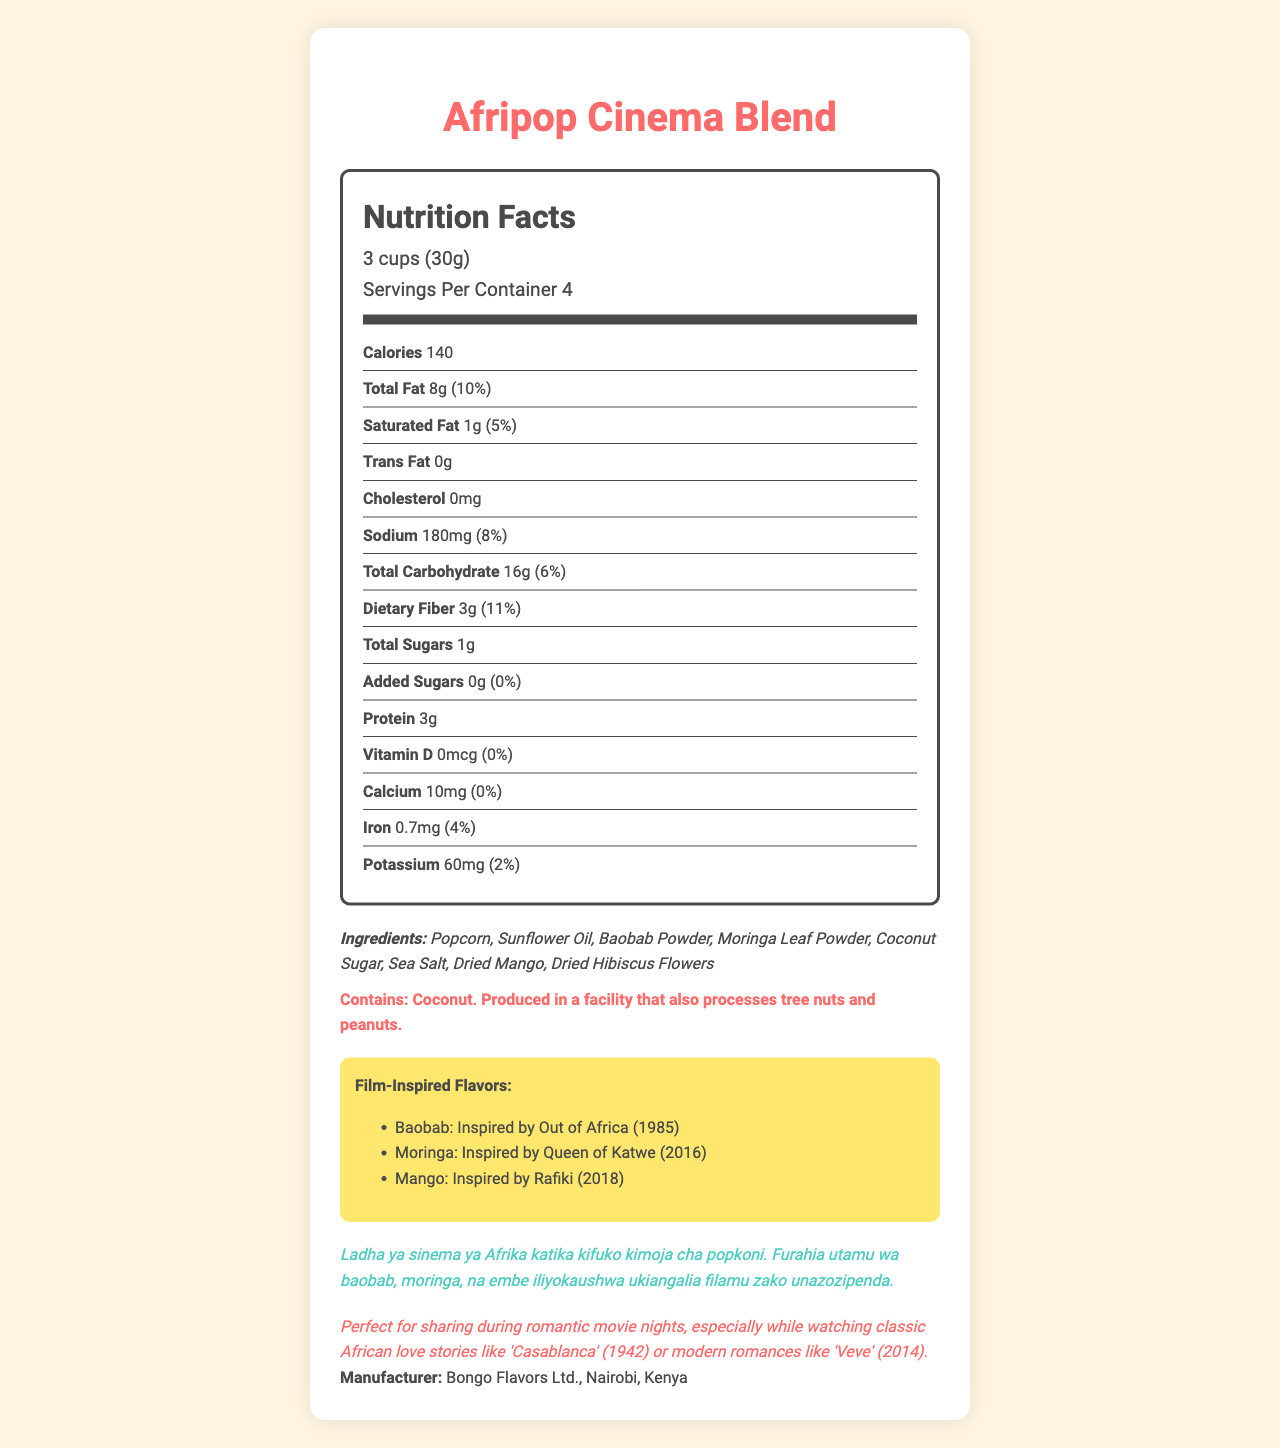what is the serving size? The serving size is located in the serving info section of the nutrition label as "3 cups (30g)".
Answer: 3 cups (30g) how many calories are in one serving? The number of calories per serving is listed under the "Calories" section of the nutrition facts.
Answer: 140 what is the total fat content per serving? The total fat content per serving is specified as "8g" in the nutrition facts and is followed by the percentage of the daily value.
Answer: 8g what ingredient in the Afripop Cinema Blend might cause an allergic reaction? The allergen information section indicates that the product contains coconut.
Answer: Coconut which nutrient contributes 11% of the daily value in one serving? The percent daily value for dietary fiber is 11%, as listed under the dietary fiber section of the nutrition facts.
Answer: Dietary Fiber what are the three film-inspired flavors in the Afripop Cinema Blend? The film-inspired flavors are listed in the film-inspired flavors section as Baobab, Moringa, and Mango.
Answer: Baobab, Moringa, Mango where is the Afripop Cinema Blend manufactured? The document states that the product is manufactured by Bongo Flavors Ltd. in Nairobi, Kenya.
Answer: Nairobi, Kenya how is the amount of sodium per serving quantified? The document quantifies the sodium content per serving as 180mg under the sodium section.
Answer: 180mg which flavor is inspired by the film "Queen of Katwe (2016)"? The film-inspired flavors section states that the Moringa flavor is inspired by "Queen of Katwe (2016)".
Answer: Moringa what is the dietary fiber content per serving, and how does it compare to the daily value percentage? A. 2g (7%) B. 3g (11%) C. 5g (15%) The dietary fiber content per serving is 3g, which is 11% of the daily value.
Answer: B which one of the following nutrients has the highest daily value percentage in one serving? A. Sodium B. Saturated Fat C. Calcium Sodium has the highest daily value percentage at 8%, compared to Saturated Fat at 5% and Calcium at 0%.
Answer: A is the Afripop Cinema Blend good for people trying to avoid added sugars? The nutrition facts show that the Afripop Cinema Blend contains 0g of added sugars, making it a good choice for those avoiding added sugars.
Answer: Yes summarize the main idea of the Afripop Cinema Blend nutrition facts label. This summary captures the overall content of the document, including the product name, serving size, nutritional details, ingredient list, allergen information, film-inspired flavors, and special notes on the product's romantic appeal.
Answer: The Afripop Cinema Blend is a specialty popcorn product inspired by African cinema, with serving size and nutritional details prominently displayed. It features flavors like Baobab, Moringa, and Mango, inspired by specific films. The product contains 140 calories per serving, with details on fats, sodium, carbohydrates, and other nutrients. The ingredient list includes items like popcorn, sunflower oil, baobab powder, and coconut sugar, and it notes allergen information related to coconut. The label also includes a Swahili product description and highlights its romantic appeal for movie nights. what is the expiration date of the Afripop Cinema Blend? The document does not provide any information regarding the expiration date of the product.
Answer: Not enough information 